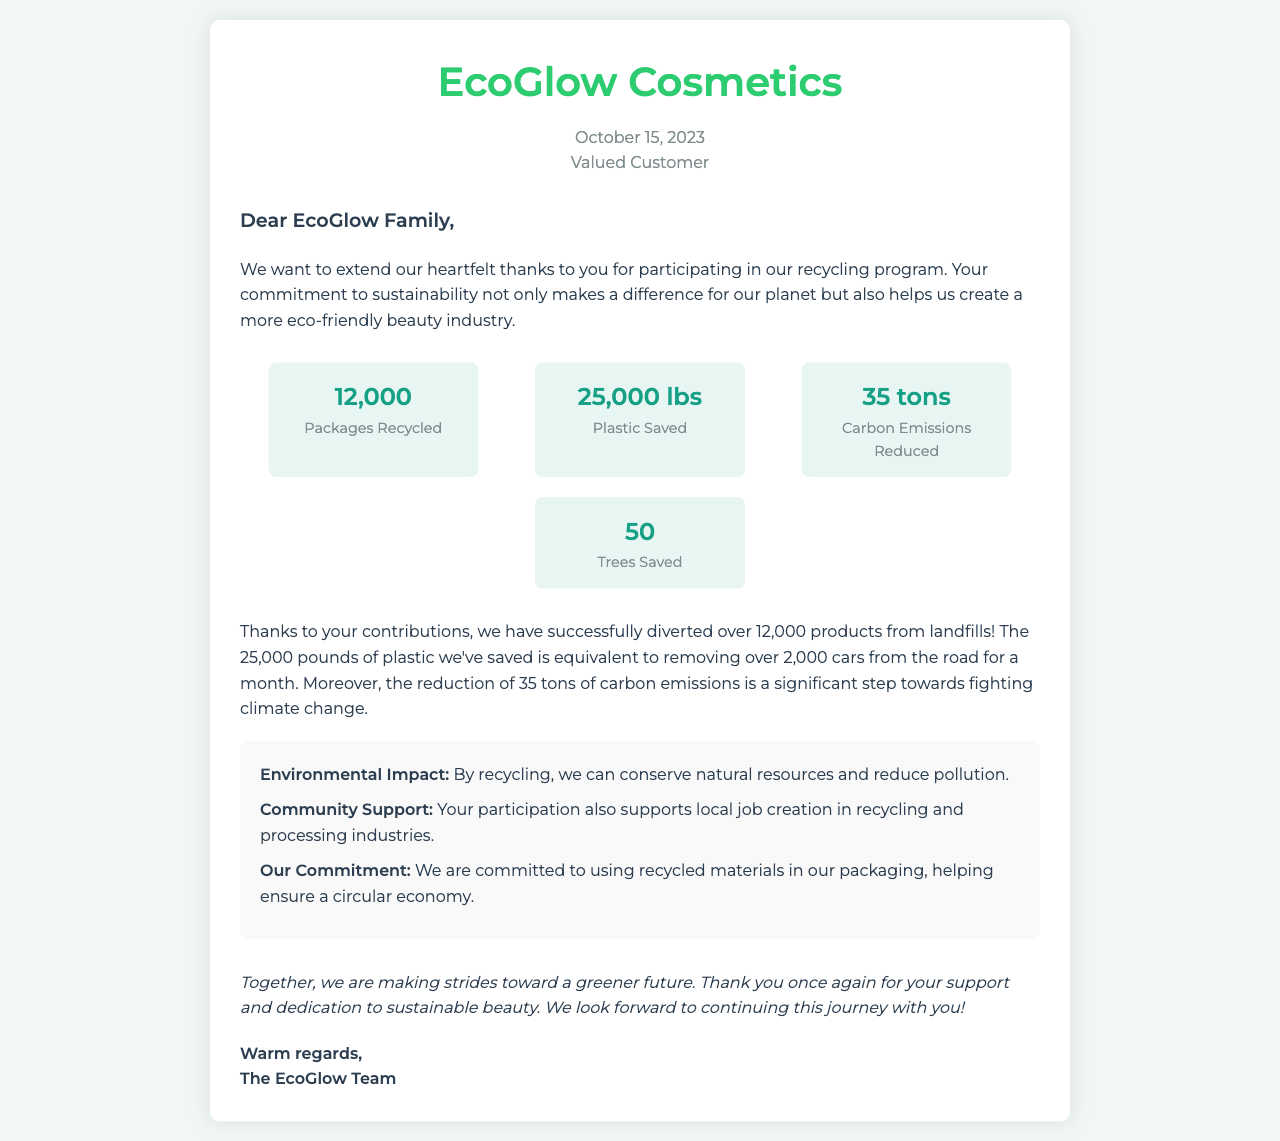What is the date of the letter? The date of the letter is found at the top of the document, indicating when it was written.
Answer: October 15, 2023 How many packages were recycled? The number of packages recycled is mentioned in the statistics section of the letter.
Answer: 12,000 What is the weight of plastic saved? The weight of plastic saved is presented alongside other statistics in the document.
Answer: 25,000 lbs How many tons of carbon emissions were reduced? The amount of carbon emissions reduced is specified in the statistics section of the letter.
Answer: 35 tons What impact does recycling have on natural resources? The document states that recycling helps conserve natural resources, highlighting its environmental benefits.
Answer: Conserves natural resources How many trees were saved through the recycling program? The letter lists the total number of trees saved as part of the impact of the program.
Answer: 50 What is the primary goal of the EcoGlow Cosmetics recycling program? The main aim of the program is emphasized in the letter, focusing on eco-friendliness and sustainability.
Answer: Sustainability What does EcoGlow Cosmetics commit to using in their packaging? The letter outlines the brand's commitment regarding the materials used in packaging as a part of their sustainability efforts.
Answer: Recycled materials 